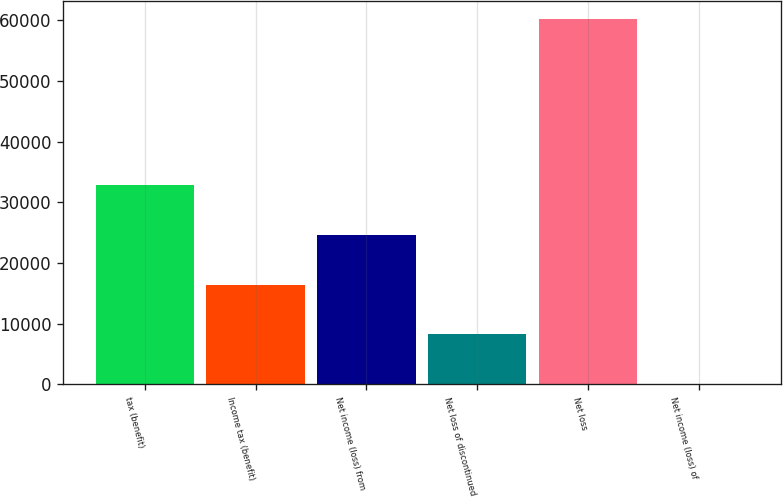<chart> <loc_0><loc_0><loc_500><loc_500><bar_chart><fcel>tax (benefit)<fcel>Income tax (benefit)<fcel>Net income (loss) from<fcel>Net loss of discontinued<fcel>Net loss<fcel>Net income (loss) of<nl><fcel>32878.4<fcel>16439.2<fcel>24658.8<fcel>8219.66<fcel>60252<fcel>0.07<nl></chart> 